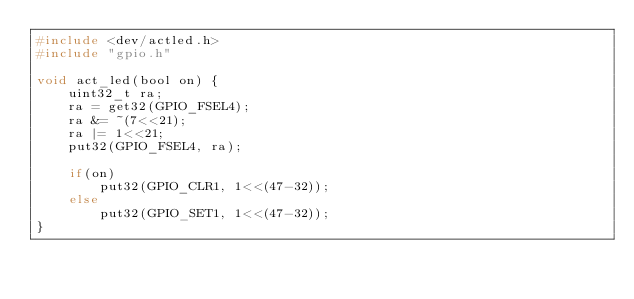Convert code to text. <code><loc_0><loc_0><loc_500><loc_500><_C_>#include <dev/actled.h>
#include "gpio.h"

void act_led(bool on) {
	uint32_t ra;
	ra = get32(GPIO_FSEL4);
	ra &= ~(7<<21);
	ra |= 1<<21;
	put32(GPIO_FSEL4, ra);

	if(on) 	
		put32(GPIO_CLR1, 1<<(47-32));
	else
		put32(GPIO_SET1, 1<<(47-32));
}
</code> 